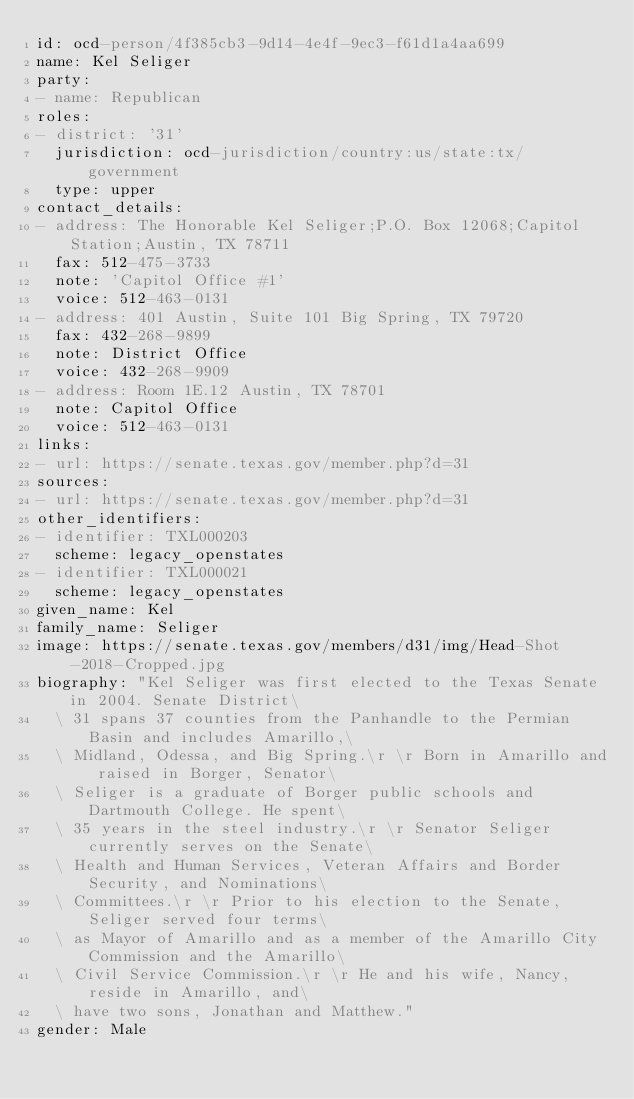<code> <loc_0><loc_0><loc_500><loc_500><_YAML_>id: ocd-person/4f385cb3-9d14-4e4f-9ec3-f61d1a4aa699
name: Kel Seliger
party:
- name: Republican
roles:
- district: '31'
  jurisdiction: ocd-jurisdiction/country:us/state:tx/government
  type: upper
contact_details:
- address: The Honorable Kel Seliger;P.O. Box 12068;Capitol Station;Austin, TX 78711
  fax: 512-475-3733
  note: 'Capitol Office #1'
  voice: 512-463-0131
- address: 401 Austin, Suite 101 Big Spring, TX 79720
  fax: 432-268-9899
  note: District Office
  voice: 432-268-9909
- address: Room 1E.12 Austin, TX 78701
  note: Capitol Office
  voice: 512-463-0131
links:
- url: https://senate.texas.gov/member.php?d=31
sources:
- url: https://senate.texas.gov/member.php?d=31
other_identifiers:
- identifier: TXL000203
  scheme: legacy_openstates
- identifier: TXL000021
  scheme: legacy_openstates
given_name: Kel
family_name: Seliger
image: https://senate.texas.gov/members/d31/img/Head-Shot-2018-Cropped.jpg
biography: "Kel Seliger was first elected to the Texas Senate in 2004. Senate District\
  \ 31 spans 37 counties from the Panhandle to the Permian Basin and includes Amarillo,\
  \ Midland, Odessa, and Big Spring.\r \r Born in Amarillo and raised in Borger, Senator\
  \ Seliger is a graduate of Borger public schools and Dartmouth College. He spent\
  \ 35 years in the steel industry.\r \r Senator Seliger currently serves on the Senate\
  \ Health and Human Services, Veteran Affairs and Border Security, and Nominations\
  \ Committees.\r \r Prior to his election to the Senate, Seliger served four terms\
  \ as Mayor of Amarillo and as a member of the Amarillo City Commission and the Amarillo\
  \ Civil Service Commission.\r \r He and his wife, Nancy, reside in Amarillo, and\
  \ have two sons, Jonathan and Matthew."
gender: Male
</code> 